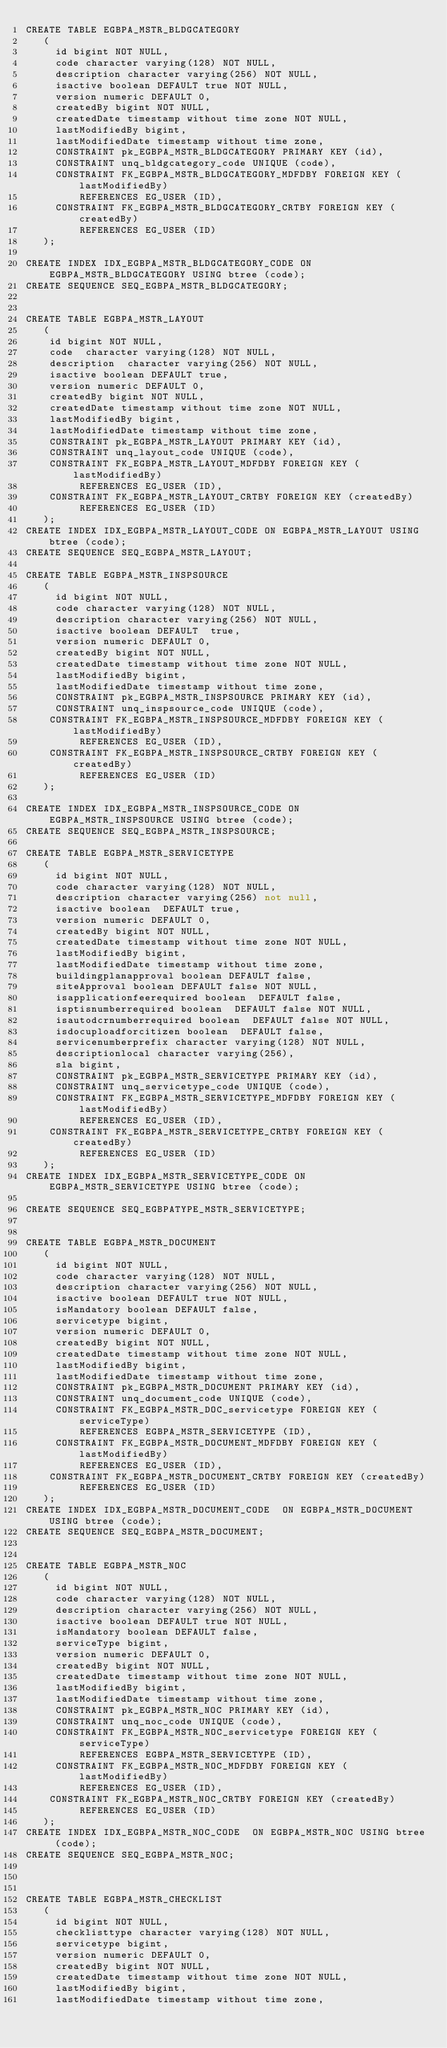Convert code to text. <code><loc_0><loc_0><loc_500><loc_500><_SQL_>CREATE TABLE EGBPA_MSTR_BLDGCATEGORY
   (	  
     id bigint NOT NULL, 
	 code character varying(128) NOT NULL,
	 description character varying(256) NOT NULL,
	 isactive boolean DEFAULT true NOT NULL,
	 version numeric DEFAULT 0,
	 createdBy bigint NOT NULL,
	 createdDate timestamp without time zone NOT NULL,
	 lastModifiedBy bigint,
     lastModifiedDate timestamp without time zone,
	 CONSTRAINT pk_EGBPA_MSTR_BLDGCATEGORY PRIMARY KEY (id),
	 CONSTRAINT unq_bldgcategory_code UNIQUE (code),
	 CONSTRAINT FK_EGBPA_MSTR_BLDGCATEGORY_MDFDBY FOREIGN KEY (lastModifiedBy)
         REFERENCES EG_USER (ID),
     CONSTRAINT FK_EGBPA_MSTR_BLDGCATEGORY_CRTBY FOREIGN KEY (createdBy)
         REFERENCES EG_USER (ID)  
   );
   
CREATE INDEX IDX_EGBPA_MSTR_BLDGCATEGORY_CODE ON EGBPA_MSTR_BLDGCATEGORY USING btree (code);   
CREATE SEQUENCE SEQ_EGBPA_MSTR_BLDGCATEGORY;


CREATE TABLE EGBPA_MSTR_LAYOUT 
   (	
    id bigint NOT NULL, 
	code  character varying(128) NOT NULL,
	description  character varying(256) NOT NULL,
	isactive boolean DEFAULT true,
	version numeric DEFAULT 0,
	createdBy bigint NOT NULL,
	createdDate timestamp without time zone NOT NULL,
	lastModifiedBy bigint,
    lastModifiedDate timestamp without time zone,
    CONSTRAINT pk_EGBPA_MSTR_LAYOUT PRIMARY KEY (id),
    CONSTRAINT unq_layout_code UNIQUE (code),
	CONSTRAINT FK_EGBPA_MSTR_LAYOUT_MDFDBY FOREIGN KEY (lastModifiedBy)
         REFERENCES EG_USER (ID),
    CONSTRAINT FK_EGBPA_MSTR_LAYOUT_CRTBY FOREIGN KEY (createdBy)
         REFERENCES EG_USER (ID)
   );
CREATE INDEX IDX_EGBPA_MSTR_LAYOUT_CODE ON EGBPA_MSTR_LAYOUT USING btree (code);      
CREATE SEQUENCE SEQ_EGBPA_MSTR_LAYOUT;   

CREATE TABLE EGBPA_MSTR_INSPSOURCE
   (	
     id bigint NOT NULL, 
	 code character varying(128) NOT NULL,
	 description character varying(256) NOT NULL,
	 isactive boolean DEFAULT  true,
	 version numeric DEFAULT 0,
	 createdBy bigint NOT NULL,
	 createdDate timestamp without time zone NOT NULL,
	 lastModifiedBy bigint,
     lastModifiedDate timestamp without time zone,
	 CONSTRAINT pk_EGBPA_MSTR_INSPSOURCE PRIMARY KEY (id),
	 CONSTRAINT unq_inspsource_code UNIQUE (code),
	CONSTRAINT FK_EGBPA_MSTR_INSPSOURCE_MDFDBY FOREIGN KEY (lastModifiedBy)
         REFERENCES EG_USER (ID),
    CONSTRAINT FK_EGBPA_MSTR_INSPSOURCE_CRTBY FOREIGN KEY (createdBy)
         REFERENCES EG_USER (ID)
   );
  
CREATE INDEX IDX_EGBPA_MSTR_INSPSOURCE_CODE ON EGBPA_MSTR_INSPSOURCE USING btree (code);    
CREATE SEQUENCE SEQ_EGBPA_MSTR_INSPSOURCE;

CREATE TABLE EGBPA_MSTR_SERVICETYPE 
   (	
	 id bigint NOT NULL, 
	 code character varying(128) NOT NULL,
	 description character varying(256) not null,
	 isactive boolean  DEFAULT true,
	 version numeric DEFAULT 0,
	 createdBy bigint NOT NULL,
	 createdDate timestamp without time zone NOT NULL,
	 lastModifiedBy bigint,
     lastModifiedDate timestamp without time zone,
     buildingplanapproval boolean DEFAULT false,
     siteApproval boolean DEFAULT false NOT NULL,
     isapplicationfeerequired boolean  DEFAULT false,
     isptisnumberrequired boolean  DEFAULT false NOT NULL,
     isautodcrnumberrequired boolean  DEFAULT false NOT NULL,
     isdocuploadforcitizen boolean  DEFAULT false,
     servicenumberprefix character varying(128) NOT NULL,
     descriptionlocal character varying(256), 
     sla bigint,
	 CONSTRAINT pk_EGBPA_MSTR_SERVICETYPE PRIMARY KEY (id),
	 CONSTRAINT unq_servicetype_code UNIQUE (code),
	 CONSTRAINT FK_EGBPA_MSTR_SERVICETYPE_MDFDBY FOREIGN KEY (lastModifiedBy)
         REFERENCES EG_USER (ID),
    CONSTRAINT FK_EGBPA_MSTR_SERVICETYPE_CRTBY FOREIGN KEY (createdBy)
         REFERENCES EG_USER (ID)
   );
CREATE INDEX IDX_EGBPA_MSTR_SERVICETYPE_CODE ON EGBPA_MSTR_SERVICETYPE USING btree (code);     
   
CREATE SEQUENCE SEQ_EGBPATYPE_MSTR_SERVICETYPE;


CREATE TABLE EGBPA_MSTR_DOCUMENT
   (	
     id bigint NOT NULL, 
	 code character varying(128) NOT NULL,
	 description character varying(256) NOT NULL,
	 isactive boolean DEFAULT true NOT NULL,
	 isMandatory boolean DEFAULT false,
	 servicetype bigint,
	 version numeric DEFAULT 0,
	 createdBy bigint NOT NULL,
	 createdDate timestamp without time zone NOT NULL,
	 lastModifiedBy bigint,
     lastModifiedDate timestamp without time zone,
	 CONSTRAINT pk_EGBPA_MSTR_DOCUMENT PRIMARY KEY (id),
	 CONSTRAINT unq_document_code UNIQUE (code),
	 CONSTRAINT FK_EGBPA_MSTR_DOC_servicetype FOREIGN KEY (serviceType)
         REFERENCES EGBPA_MSTR_SERVICETYPE (ID),
	 CONSTRAINT FK_EGBPA_MSTR_DOCUMENT_MDFDBY FOREIGN KEY (lastModifiedBy)
         REFERENCES EG_USER (ID),
    CONSTRAINT FK_EGBPA_MSTR_DOCUMENT_CRTBY FOREIGN KEY (createdBy)
         REFERENCES EG_USER (ID)
   );
CREATE INDEX IDX_EGBPA_MSTR_DOCUMENT_CODE  ON EGBPA_MSTR_DOCUMENT USING btree (code);   
CREATE SEQUENCE SEQ_EGBPA_MSTR_DOCUMENT;


CREATE TABLE EGBPA_MSTR_NOC
   (	
     id bigint NOT NULL, 
	 code character varying(128) NOT NULL,
	 description character varying(256) NOT NULL,
	 isactive boolean DEFAULT true NOT NULL,
	 isMandatory boolean DEFAULT false,
	 serviceType bigint,
	 version numeric DEFAULT 0,
	 createdBy bigint NOT NULL,
	 createdDate timestamp without time zone NOT NULL,
	 lastModifiedBy bigint,
     lastModifiedDate timestamp without time zone,
	 CONSTRAINT pk_EGBPA_MSTR_NOC PRIMARY KEY (id),
	 CONSTRAINT unq_noc_code UNIQUE (code),
	 CONSTRAINT FK_EGBPA_MSTR_NOC_servicetype FOREIGN KEY (serviceType)
         REFERENCES EGBPA_MSTR_SERVICETYPE (ID),
	 CONSTRAINT FK_EGBPA_MSTR_NOC_MDFDBY FOREIGN KEY (lastModifiedBy)
         REFERENCES EG_USER (ID),
    CONSTRAINT FK_EGBPA_MSTR_NOC_CRTBY FOREIGN KEY (createdBy)
         REFERENCES EG_USER (ID)
   );
CREATE INDEX IDX_EGBPA_MSTR_NOC_CODE  ON EGBPA_MSTR_NOC USING btree (code);   
CREATE SEQUENCE SEQ_EGBPA_MSTR_NOC;

 

CREATE TABLE EGBPA_MSTR_CHECKLIST
   (	
     id bigint NOT NULL, 
	 checklisttype character varying(128) NOT NULL,
	 servicetype bigint,
	 version numeric DEFAULT 0,
	 createdBy bigint NOT NULL,
	 createdDate timestamp without time zone NOT NULL,
	 lastModifiedBy bigint,
     lastModifiedDate timestamp without time zone,</code> 